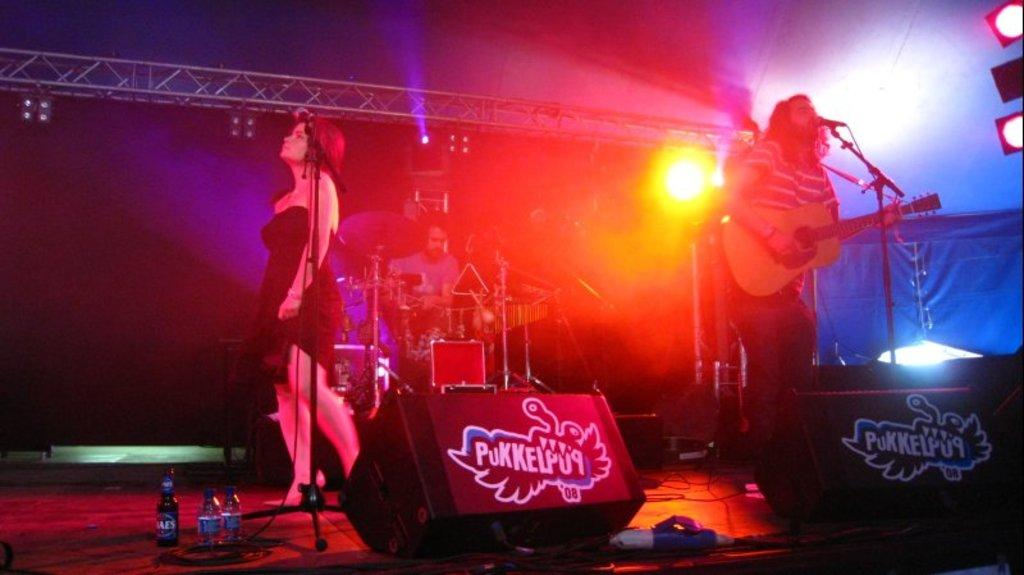What are the people on the stage doing? The people on the stage are performing by playing musical instruments. What can be seen on the stage besides the people? There is a wine bottle and water bottles on the stage. What is visible in the background of the image? There are lights and poles in the background. Can you see any sand on the stage in the image? No, there is no sand visible on the stage in the image. Is there a zebra performing with the people on the stage? No, there is no zebra present in the image; only people playing musical instruments are visible. 